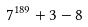<formula> <loc_0><loc_0><loc_500><loc_500>7 ^ { 1 8 9 } + 3 - 8</formula> 